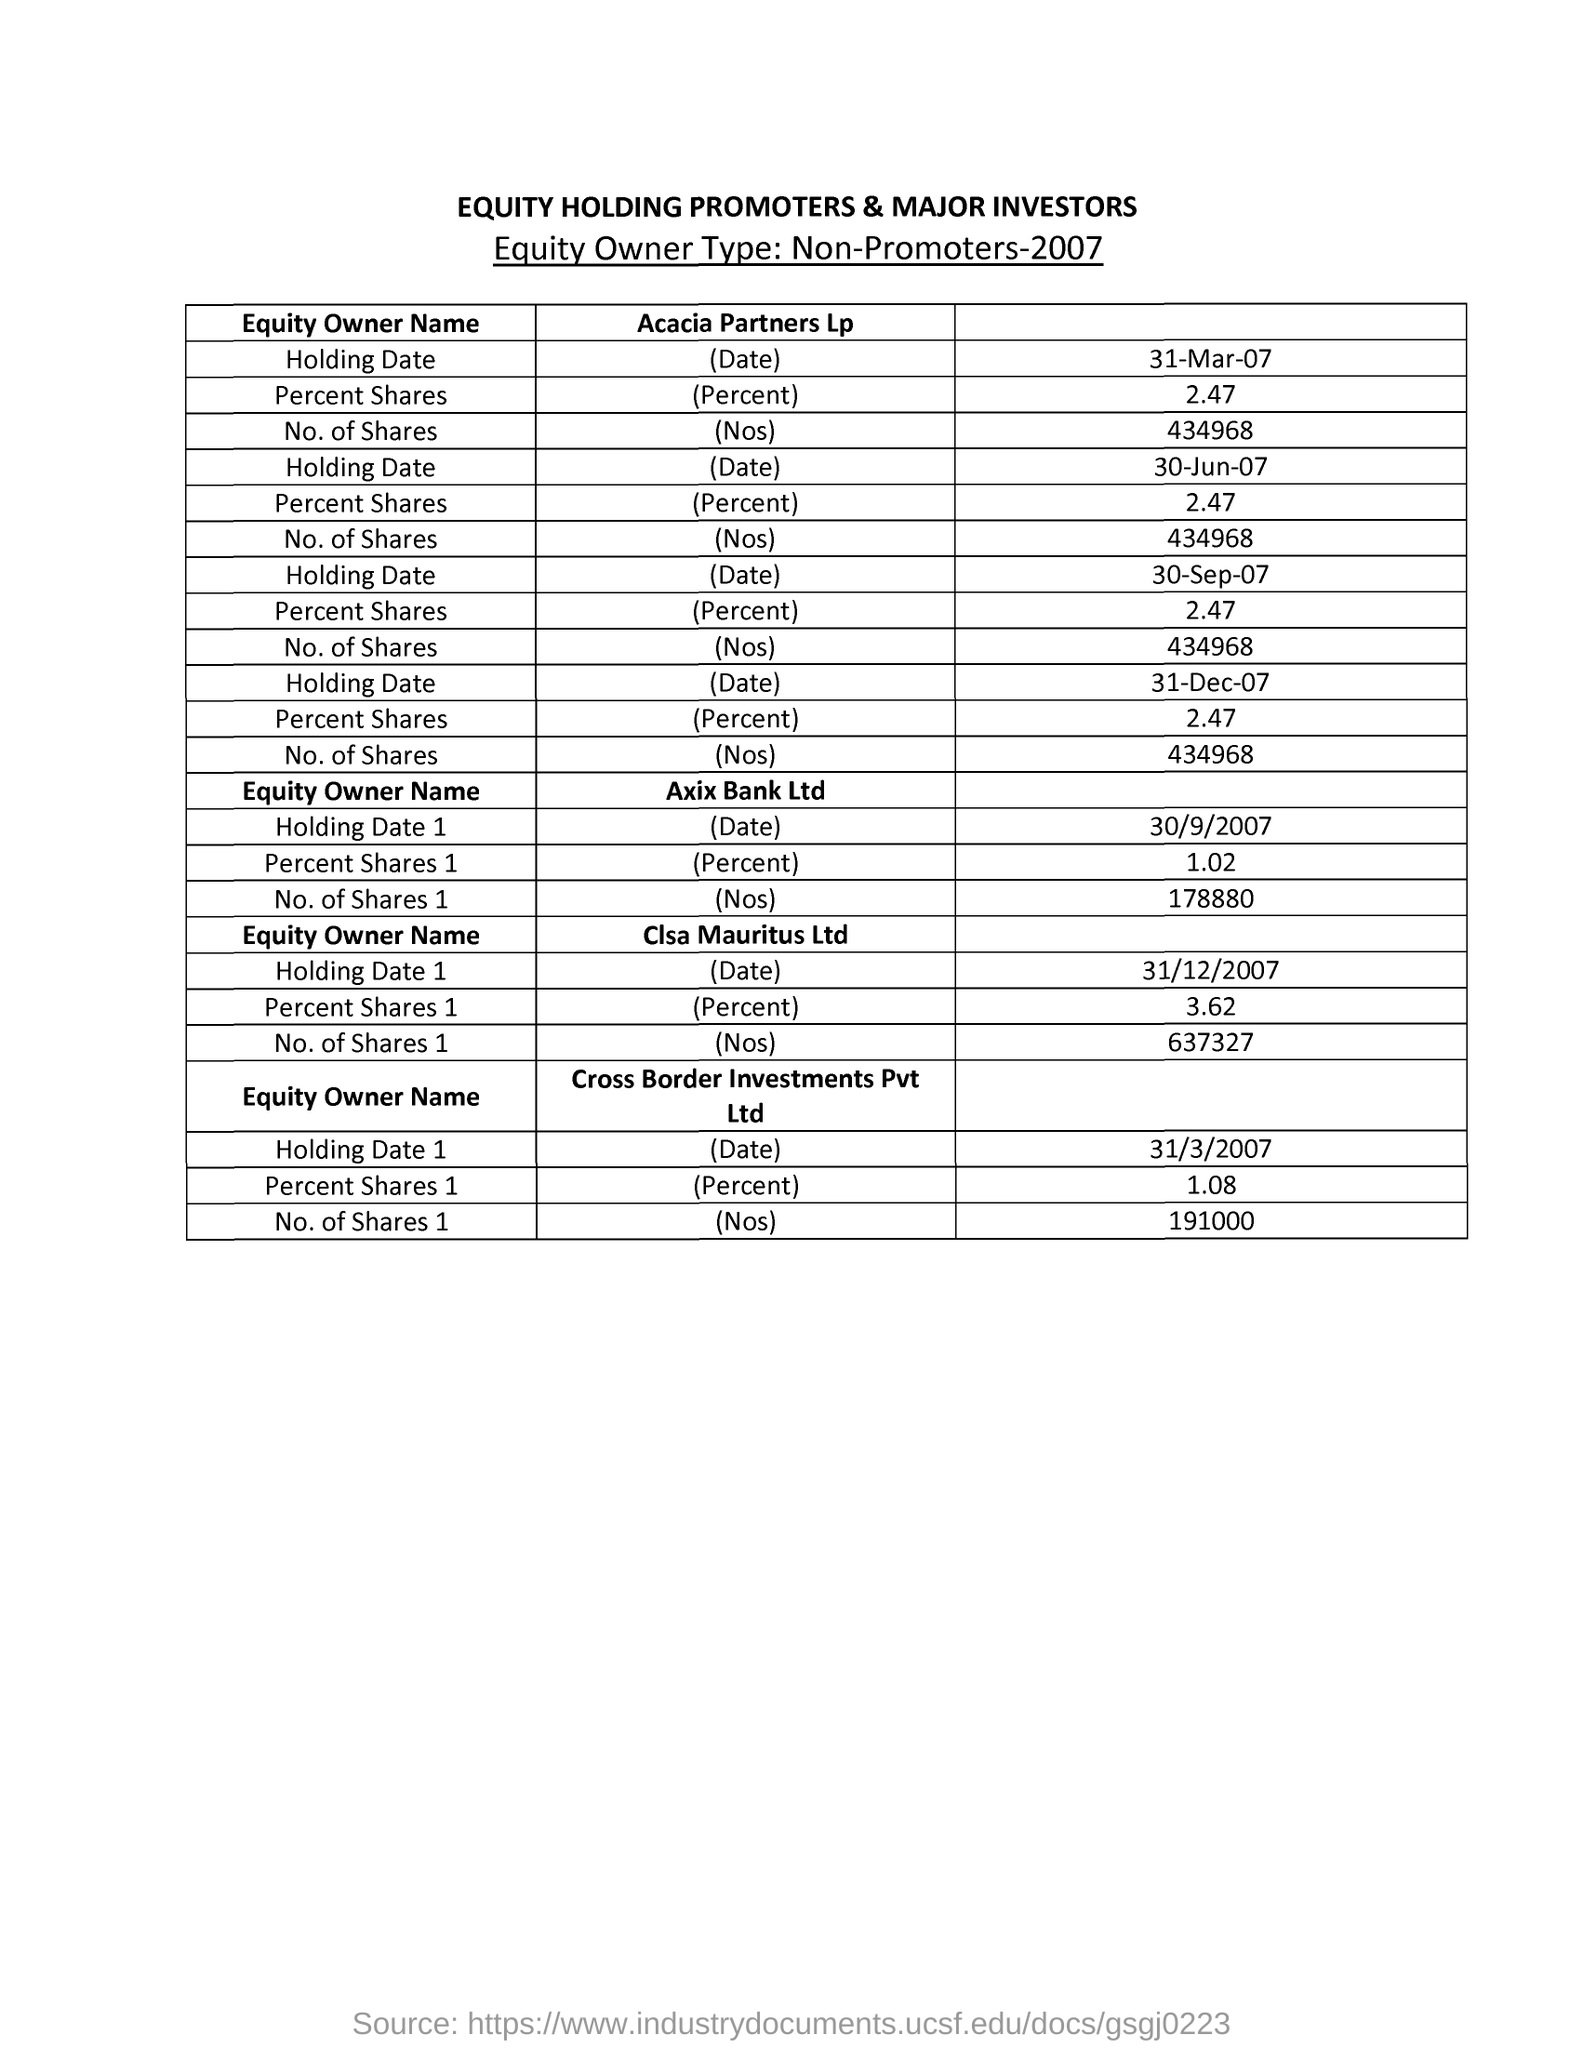How many percent shares did Clsa Mauritus Ltd have?
Your response must be concise. 3.62. How many number of shares did Axis Bank Ltd have ?
Your response must be concise. 178880. What is the holding date of the axis bank ltd ?
Offer a terse response. 30/9/2007. 